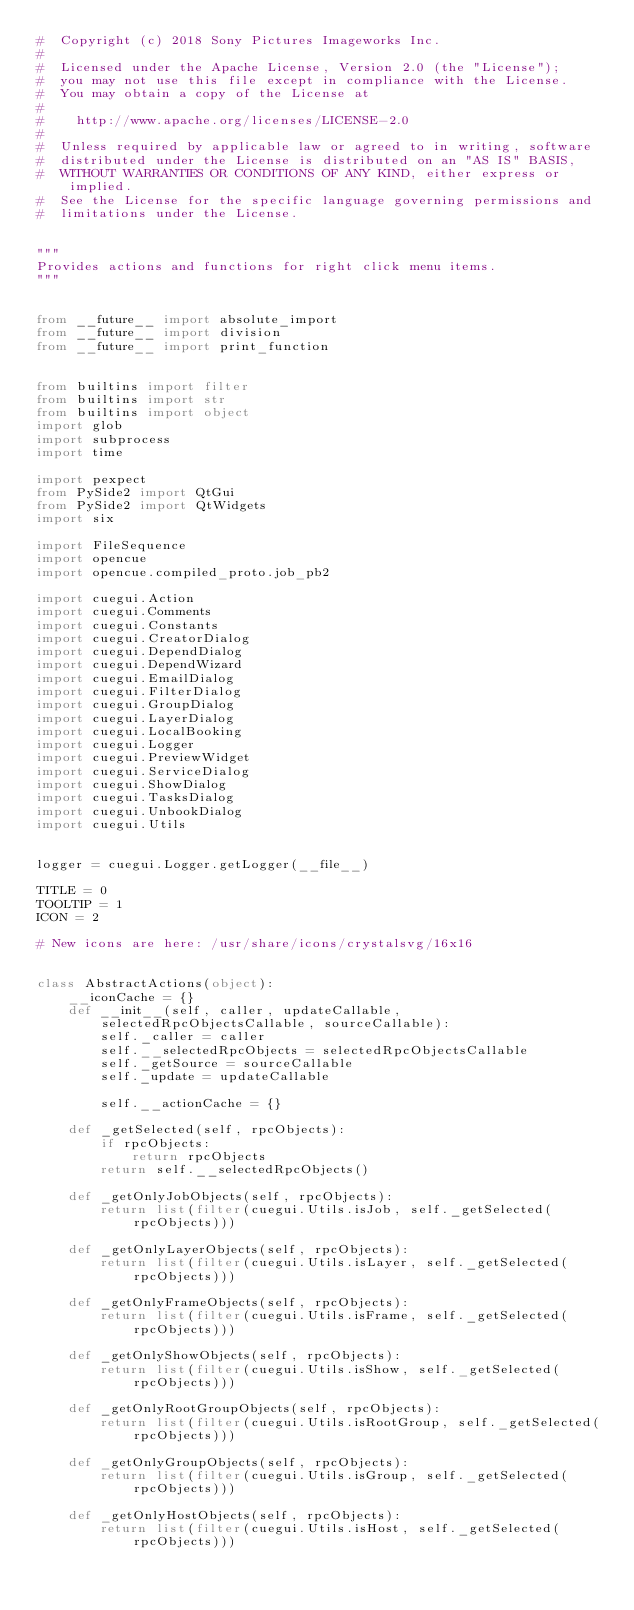Convert code to text. <code><loc_0><loc_0><loc_500><loc_500><_Python_>#  Copyright (c) 2018 Sony Pictures Imageworks Inc.
#
#  Licensed under the Apache License, Version 2.0 (the "License");
#  you may not use this file except in compliance with the License.
#  You may obtain a copy of the License at
#
#    http://www.apache.org/licenses/LICENSE-2.0
#
#  Unless required by applicable law or agreed to in writing, software
#  distributed under the License is distributed on an "AS IS" BASIS,
#  WITHOUT WARRANTIES OR CONDITIONS OF ANY KIND, either express or implied.
#  See the License for the specific language governing permissions and
#  limitations under the License.


"""
Provides actions and functions for right click menu items.
"""


from __future__ import absolute_import
from __future__ import division
from __future__ import print_function


from builtins import filter
from builtins import str
from builtins import object
import glob
import subprocess
import time

import pexpect
from PySide2 import QtGui
from PySide2 import QtWidgets
import six

import FileSequence
import opencue
import opencue.compiled_proto.job_pb2

import cuegui.Action
import cuegui.Comments
import cuegui.Constants
import cuegui.CreatorDialog
import cuegui.DependDialog
import cuegui.DependWizard
import cuegui.EmailDialog
import cuegui.FilterDialog
import cuegui.GroupDialog
import cuegui.LayerDialog
import cuegui.LocalBooking
import cuegui.Logger
import cuegui.PreviewWidget
import cuegui.ServiceDialog
import cuegui.ShowDialog
import cuegui.TasksDialog
import cuegui.UnbookDialog
import cuegui.Utils


logger = cuegui.Logger.getLogger(__file__)

TITLE = 0
TOOLTIP = 1
ICON = 2

# New icons are here: /usr/share/icons/crystalsvg/16x16


class AbstractActions(object):
    __iconCache = {}
    def __init__(self, caller, updateCallable, selectedRpcObjectsCallable, sourceCallable):
        self._caller = caller
        self.__selectedRpcObjects = selectedRpcObjectsCallable
        self._getSource = sourceCallable
        self._update = updateCallable

        self.__actionCache = {}

    def _getSelected(self, rpcObjects):
        if rpcObjects:
            return rpcObjects
        return self.__selectedRpcObjects()

    def _getOnlyJobObjects(self, rpcObjects):
        return list(filter(cuegui.Utils.isJob, self._getSelected(rpcObjects)))

    def _getOnlyLayerObjects(self, rpcObjects):
        return list(filter(cuegui.Utils.isLayer, self._getSelected(rpcObjects)))

    def _getOnlyFrameObjects(self, rpcObjects):
        return list(filter(cuegui.Utils.isFrame, self._getSelected(rpcObjects)))

    def _getOnlyShowObjects(self, rpcObjects):
        return list(filter(cuegui.Utils.isShow, self._getSelected(rpcObjects)))

    def _getOnlyRootGroupObjects(self, rpcObjects):
        return list(filter(cuegui.Utils.isRootGroup, self._getSelected(rpcObjects)))

    def _getOnlyGroupObjects(self, rpcObjects):
        return list(filter(cuegui.Utils.isGroup, self._getSelected(rpcObjects)))

    def _getOnlyHostObjects(self, rpcObjects):
        return list(filter(cuegui.Utils.isHost, self._getSelected(rpcObjects)))
</code> 